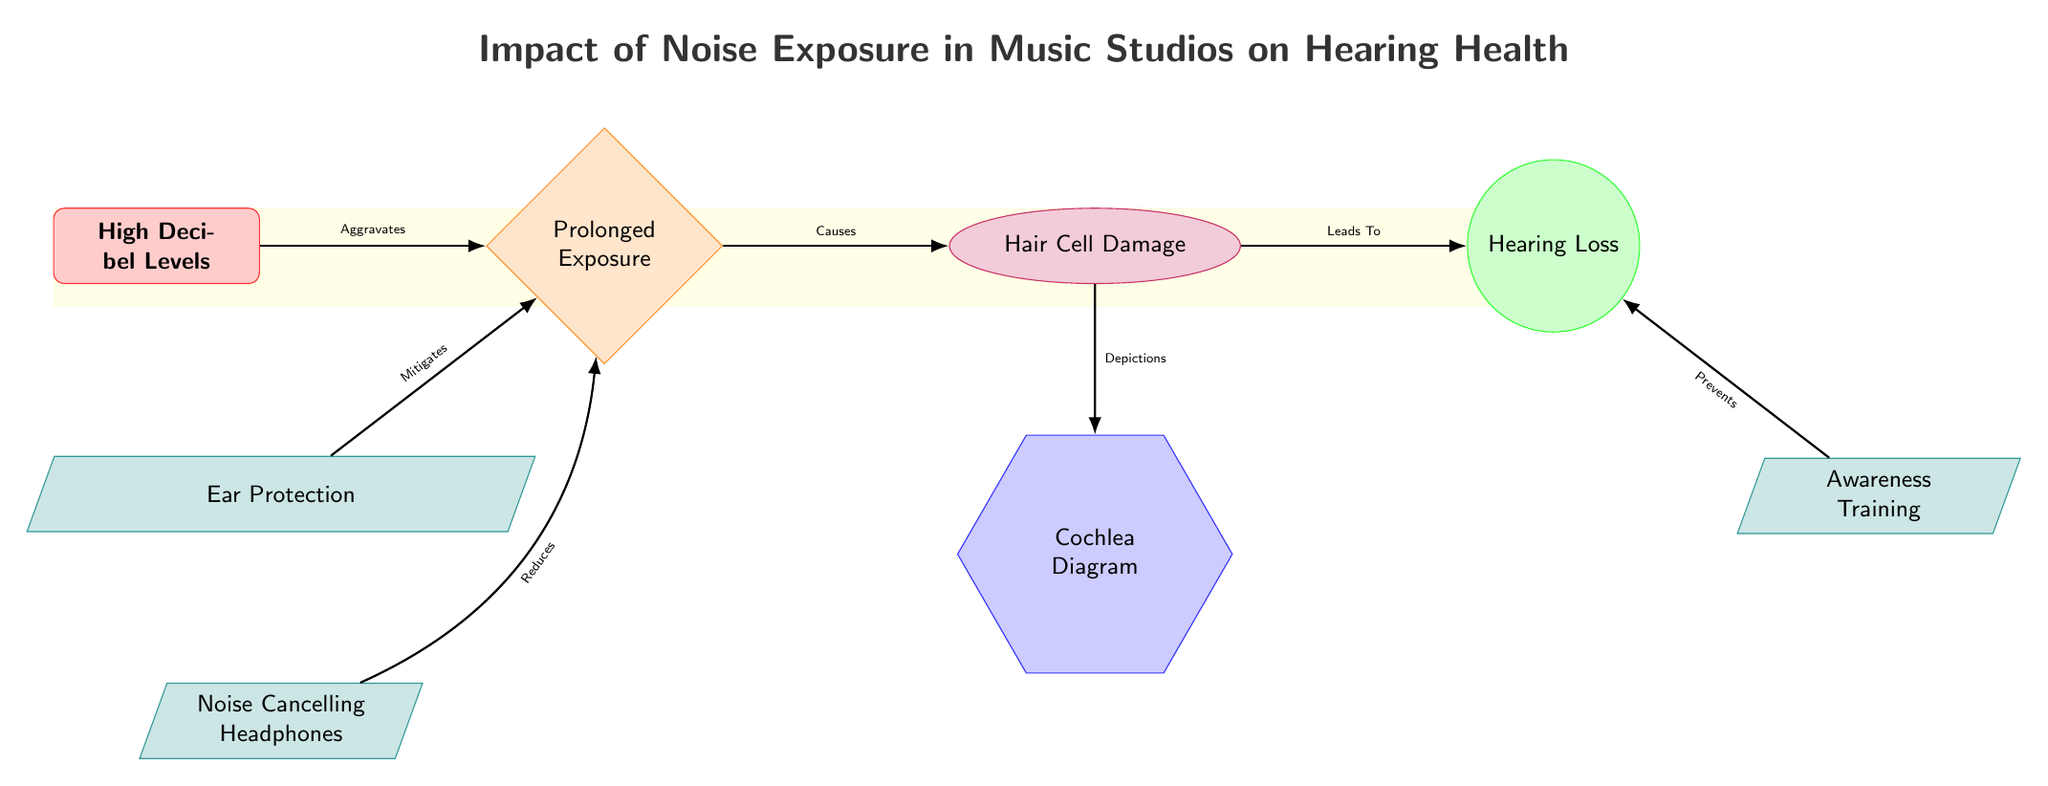What are the hazards represented in the diagram? The hazards in the diagram are identified through the node labeled "High Decibel Levels". Hazards typically represent risks or dangers, and this one indicates an environmental concern leading to hearing health issues.
Answer: High Decibel Levels How many preventative strategies are illustrated in the diagram? The diagram shows three different preventative strategies: "Ear Protection", "Noise Cancelling Headphones", and "Awareness Training". To count these, I locate and tally the nodes that fall under the preventative category.
Answer: 3 What does prolonged exposure lead to according to the diagram? The connection between "Prolonged Exposure" and "Hair Cell Damage" indicates that prolonged exposure directly causes hair cell damage. This relationship is labeled with "Causes", describing how one condition triggers another in the flow of the diagram.
Answer: Hair Cell Damage Which node represents the outcome of hearing damage? The outcome node is labeled "Hearing Loss". This node is the final consequence in the flowchart, directly stemming from "Hair Cell Damage" and indicating the end result of the preceding conditions.
Answer: Hearing Loss What is the role of ear protection as described in the diagram? The node labeled "Ear Protection" has a connection indicating it "Mitigates" prolonged exposure to high decibel levels. This relationship shows that using ear protection can help decrease the risk of hearing damage due to high noise levels.
Answer: Mitigates What is related to the depiction of hair cell damage? The diagram includes a node labeled "Cochlea Diagram" that is connected to "Hair Cell Damage". This indicates that the cochlea diagram visually illustrates the effects of hair cell damage, connecting the conceptual understanding with a visual representation.
Answer: Cochlea Diagram How does awareness training impact hearing loss? The relationship shown in the diagram states that "Awareness Training" prevents hearing loss. This means through education and training, producers can learn methods to protect their hearing, thus reducing the risk of eventual hearing loss.
Answer: Prevents In the diagram, what is the consequence of hair cell damage? The diagram indicates that hair cell damage leads to the consequence labeled "Hearing Loss". This shows a clear causal relationship between the two nodes, with hearing loss being the unfortunate result of hair cell damage that stems from prolonged noise exposure.
Answer: Hearing Loss 